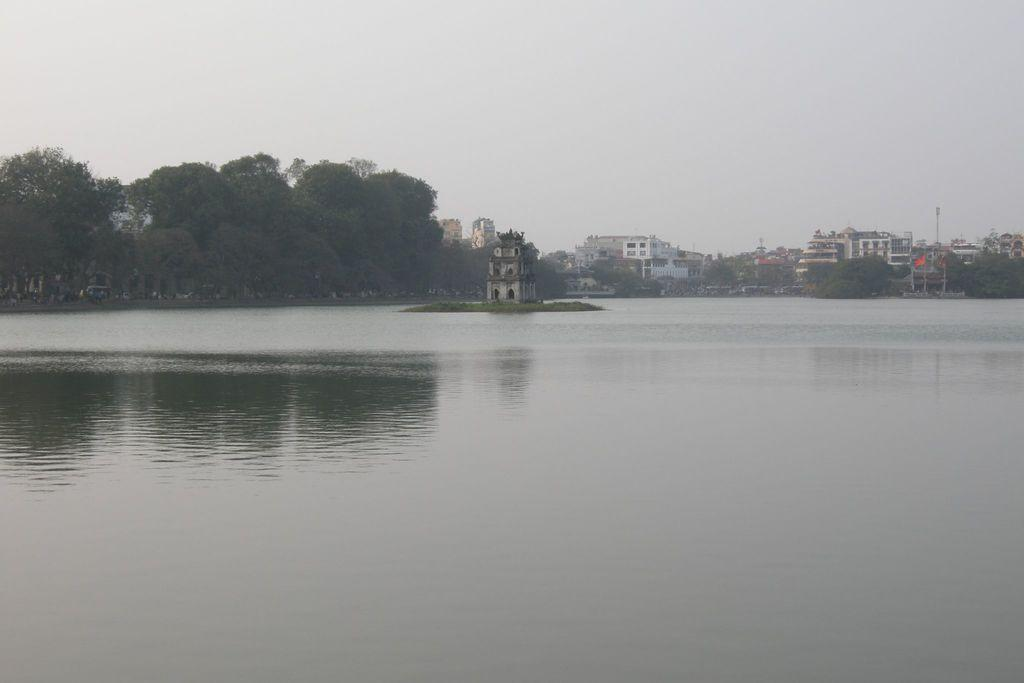What type of structure is located on the water in the image? There is a building on the water in the image. What can be seen in the background of the image? There are trees, buildings, a tower, and the sky visible in the background of the image. What is at the bottom of the image? There is water at the bottom of the image. What type of pie is being served at the event in the image? There is no event or pie present in the image; it features a building on the water with a background of trees, buildings, a tower, and the sky. 